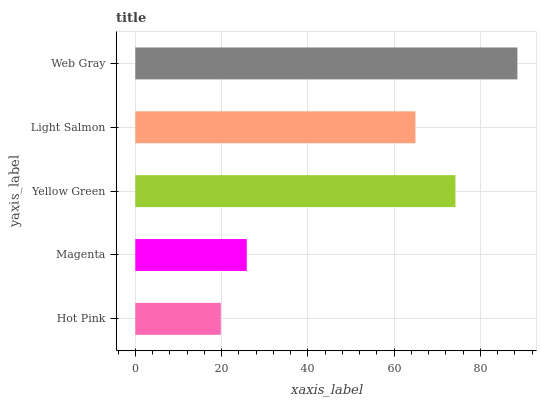Is Hot Pink the minimum?
Answer yes or no. Yes. Is Web Gray the maximum?
Answer yes or no. Yes. Is Magenta the minimum?
Answer yes or no. No. Is Magenta the maximum?
Answer yes or no. No. Is Magenta greater than Hot Pink?
Answer yes or no. Yes. Is Hot Pink less than Magenta?
Answer yes or no. Yes. Is Hot Pink greater than Magenta?
Answer yes or no. No. Is Magenta less than Hot Pink?
Answer yes or no. No. Is Light Salmon the high median?
Answer yes or no. Yes. Is Light Salmon the low median?
Answer yes or no. Yes. Is Web Gray the high median?
Answer yes or no. No. Is Web Gray the low median?
Answer yes or no. No. 